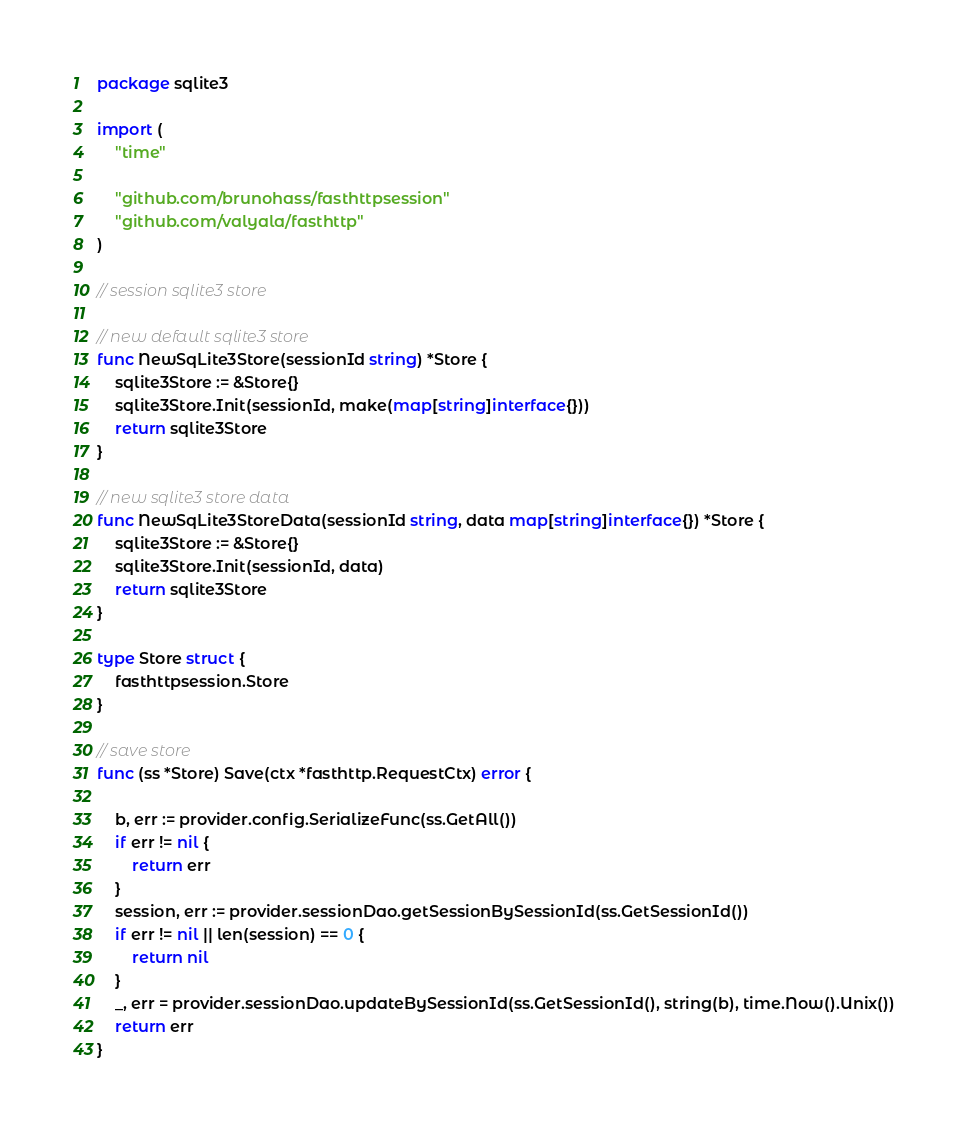Convert code to text. <code><loc_0><loc_0><loc_500><loc_500><_Go_>package sqlite3

import (
	"time"

	"github.com/brunohass/fasthttpsession"
	"github.com/valyala/fasthttp"
)

// session sqlite3 store

// new default sqlite3 store
func NewSqLite3Store(sessionId string) *Store {
	sqlite3Store := &Store{}
	sqlite3Store.Init(sessionId, make(map[string]interface{}))
	return sqlite3Store
}

// new sqlite3 store data
func NewSqLite3StoreData(sessionId string, data map[string]interface{}) *Store {
	sqlite3Store := &Store{}
	sqlite3Store.Init(sessionId, data)
	return sqlite3Store
}

type Store struct {
	fasthttpsession.Store
}

// save store
func (ss *Store) Save(ctx *fasthttp.RequestCtx) error {

	b, err := provider.config.SerializeFunc(ss.GetAll())
	if err != nil {
		return err
	}
	session, err := provider.sessionDao.getSessionBySessionId(ss.GetSessionId())
	if err != nil || len(session) == 0 {
		return nil
	}
	_, err = provider.sessionDao.updateBySessionId(ss.GetSessionId(), string(b), time.Now().Unix())
	return err
}
</code> 